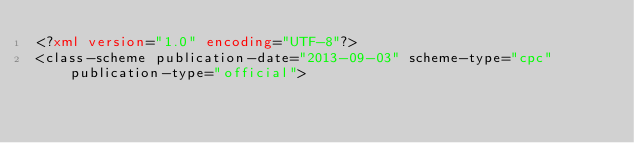<code> <loc_0><loc_0><loc_500><loc_500><_XML_><?xml version="1.0" encoding="UTF-8"?>
<class-scheme publication-date="2013-09-03" scheme-type="cpc" publication-type="official"> </code> 